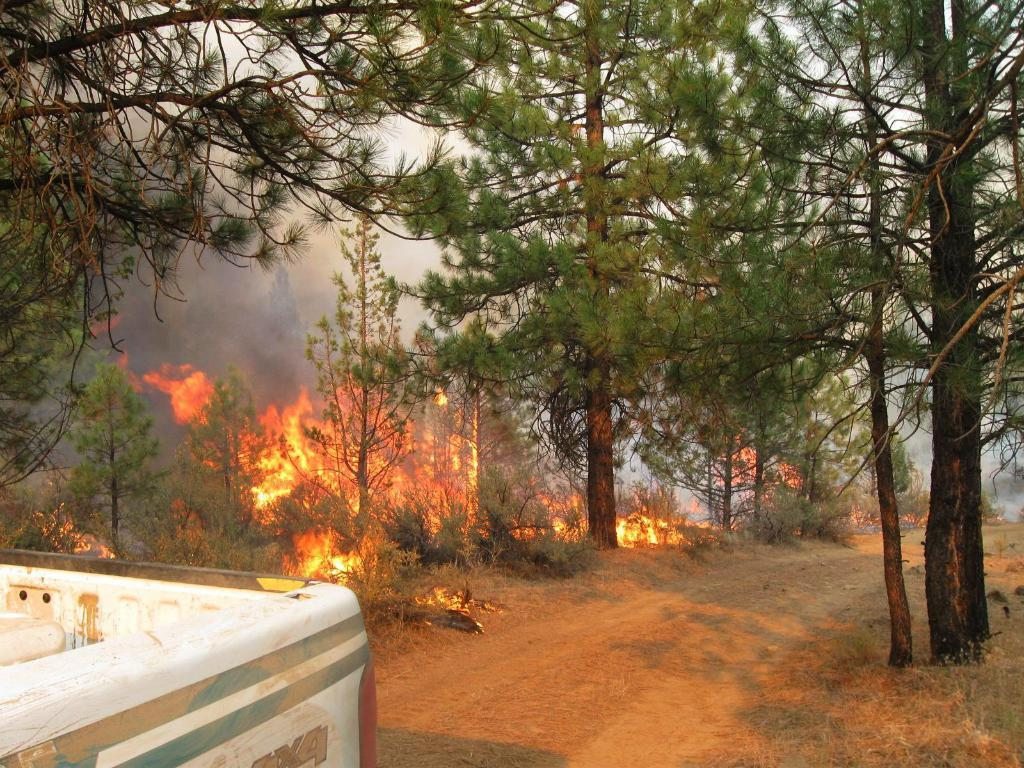What is the main subject in the image? There is a vehicle in the image. What type of natural environment is visible in the image? There is grass, plants, and trees in the image. What is the condition of the plants in the image? The plants are on fire in the image. What is the result of the burning plants? There is smoke in the image as a result of the burning plants. What can be seen in the background of the image? The sky is visible in the background of the image. What type of ink is being used to write on the plant in the image? There is no ink or writing present on the plant in the image; the plants are on fire. 